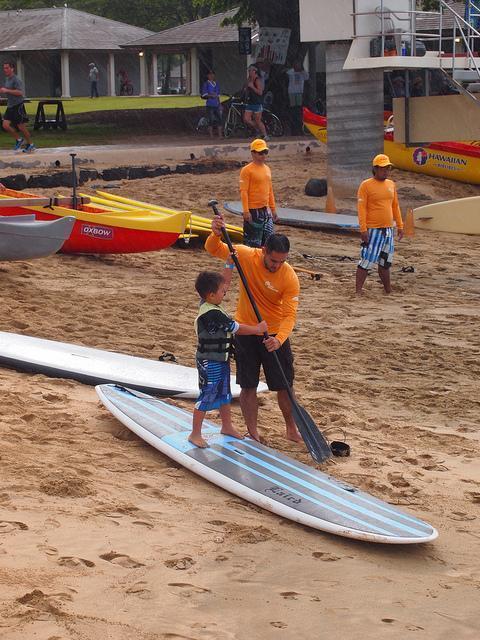The small person here learns how to do what?
Choose the correct response and explain in the format: 'Answer: answer
Rationale: rationale.'
Options: Ski, boogie board, sail, paddle board. Answer: paddle board.
Rationale: The person is on a paddle board. 